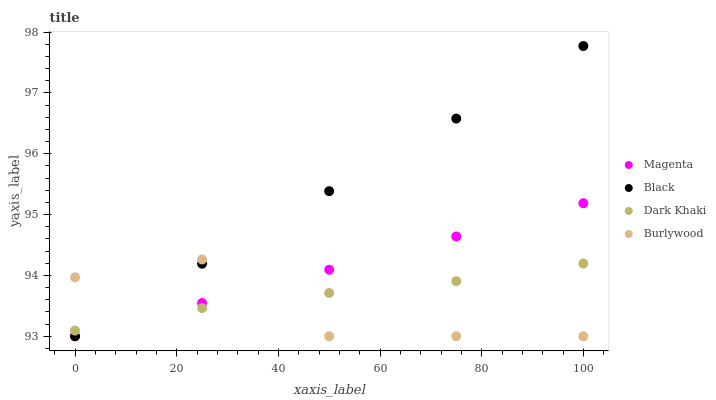Does Burlywood have the minimum area under the curve?
Answer yes or no. Yes. Does Black have the maximum area under the curve?
Answer yes or no. Yes. Does Magenta have the minimum area under the curve?
Answer yes or no. No. Does Magenta have the maximum area under the curve?
Answer yes or no. No. Is Magenta the smoothest?
Answer yes or no. Yes. Is Burlywood the roughest?
Answer yes or no. Yes. Is Burlywood the smoothest?
Answer yes or no. No. Is Magenta the roughest?
Answer yes or no. No. Does Burlywood have the lowest value?
Answer yes or no. Yes. Does Black have the highest value?
Answer yes or no. Yes. Does Burlywood have the highest value?
Answer yes or no. No. Does Dark Khaki intersect Burlywood?
Answer yes or no. Yes. Is Dark Khaki less than Burlywood?
Answer yes or no. No. Is Dark Khaki greater than Burlywood?
Answer yes or no. No. 